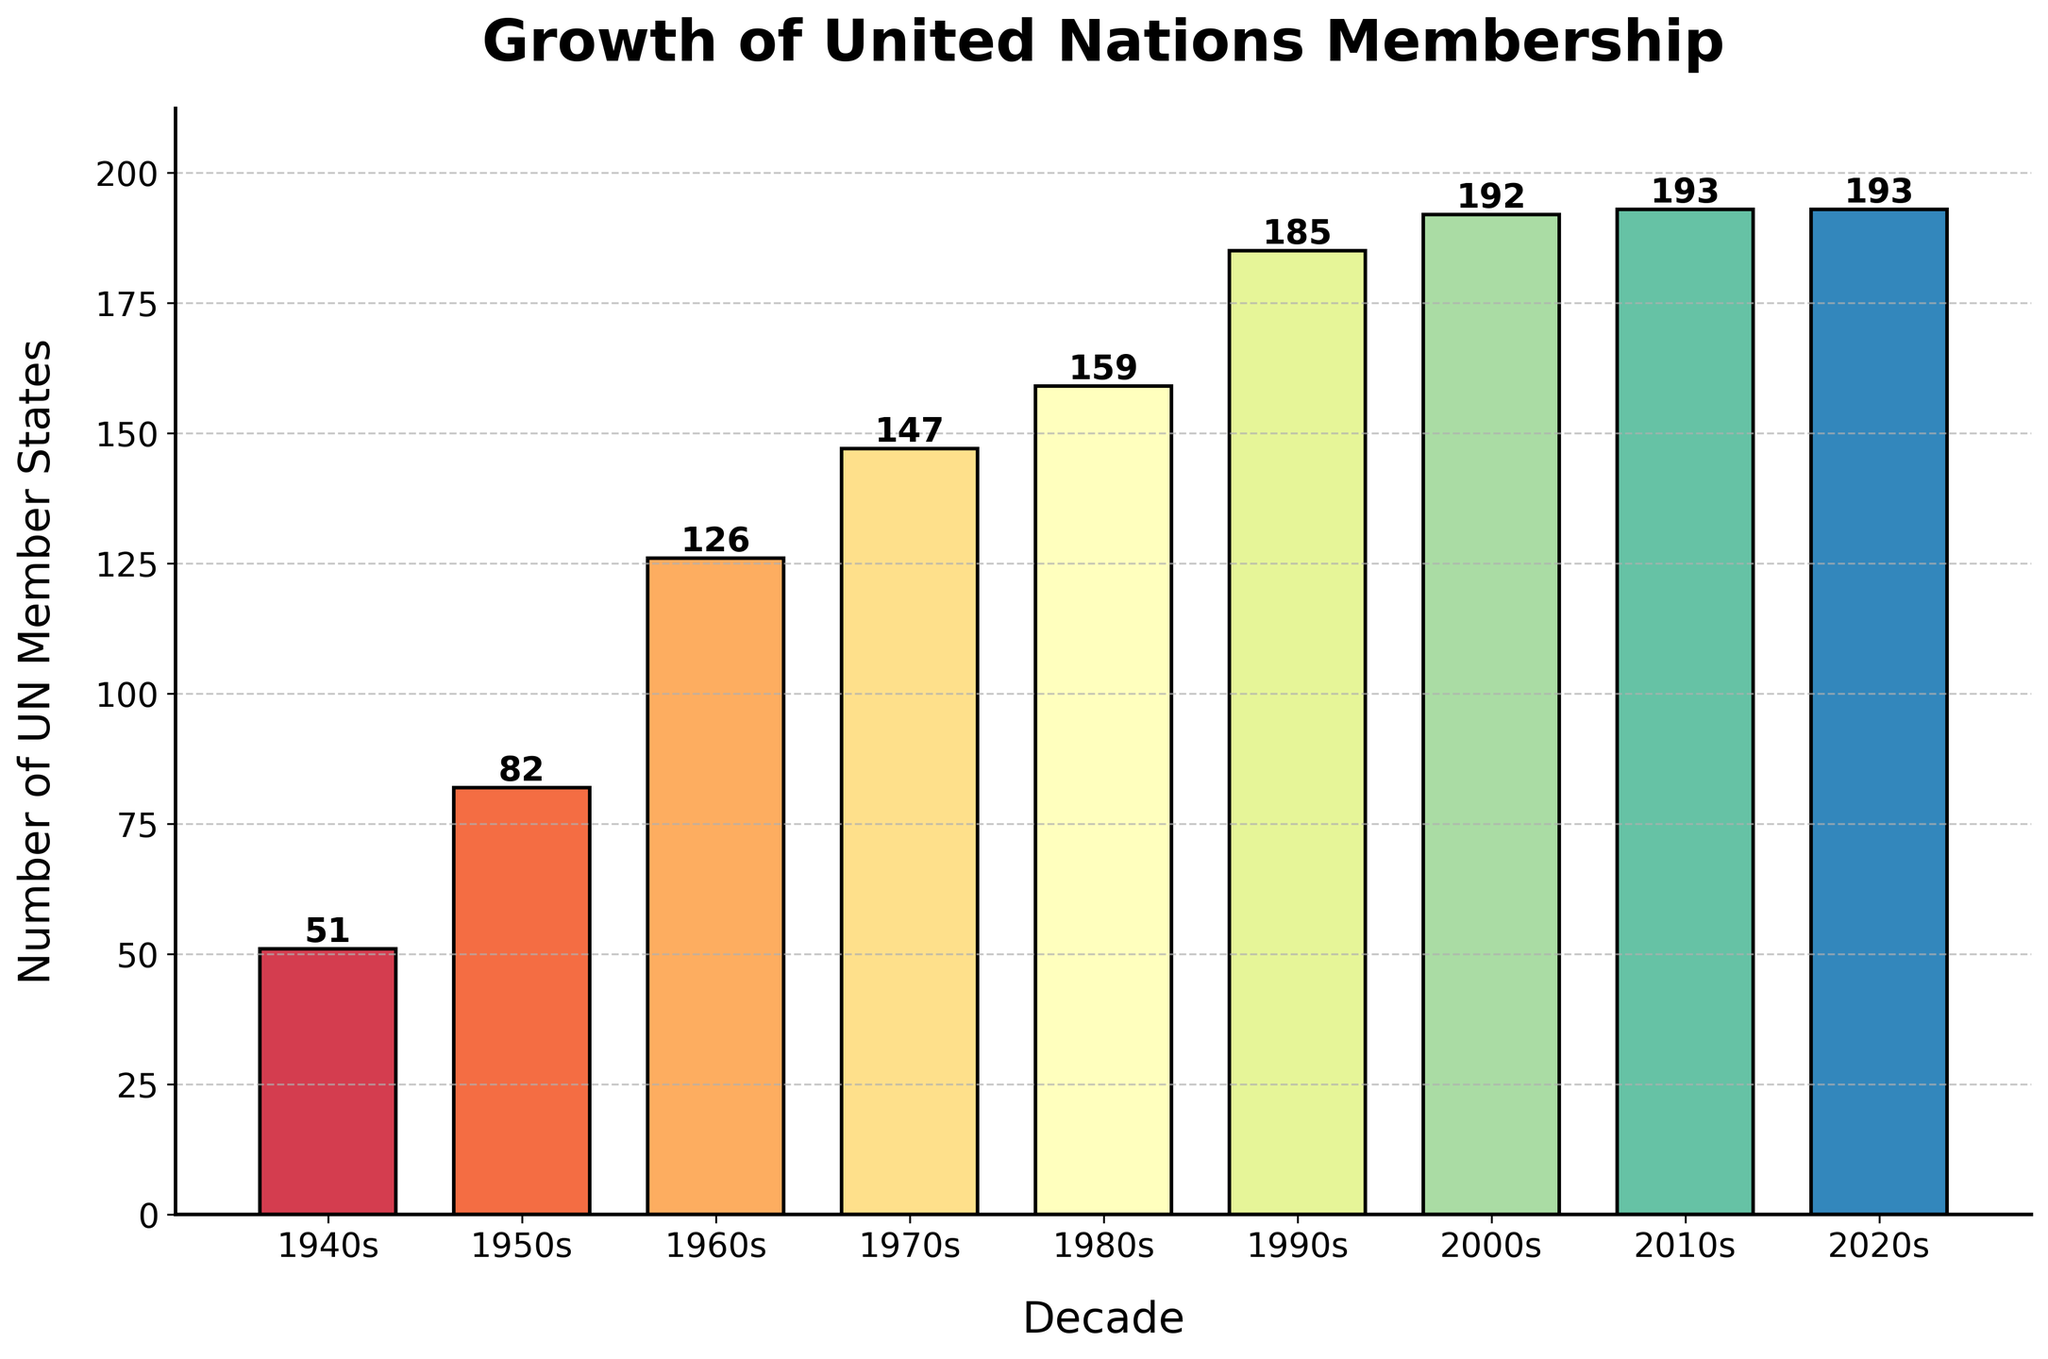What is the total increase in the number of UN member states from the 1940s to the 2020s? To find the total increase, subtract the number of states in the 1940s from that in the 2020s: 193 - 51 = 142
Answer: 142 Which decade saw the highest increase in the number of UN member states? Subtract the number of members of each decade from the previous one and identify the highest increase: 1950s: 82 - 51 = 31, 1960s: 126 - 82 = 44, 1970s: 147 - 126 = 21, 1980s: 159 - 147 = 12, 1990s: 185 - 159 = 26, 2000s: 192 - 185 = 7, 2010s: 193 - 192 = 1, 2020s: 193 - 193 = 0. The 1960s saw the highest increase of 44.
Answer: 1960s Compare the number of UN member states in the 1980s to the 1990s. Which decade had more member states and by how much? Subtract the number of member states in the 1980s from the number in the 1990s: 185 - 159 = 26. There are 26 more states in the 1990s.
Answer: 1990s by 26 What is the average number of UN member states from the 1940s to the 2020s? Calculate the average by summing the number of member states and dividing by the number of decades: (51 + 82 + 126 + 147 + 159 + 185 + 192 + 193 + 193) / 9 = 117.55 ≈ 118
Answer: 118 In which decade did the number of UN member states first exceed 100? Look at the numbers by decade and identify the first instance exceeding 100: 126 in the 1960s.
Answer: 1960s What is the difference in the number of UN member states between the 2010s and the 2000s? Subtract the number of member states in the 2000s from the number in the 2010s: 193 - 192 = 1.
Answer: 1 Visually, which decade has the tallest bar, indicating the highest number of UN member states? The 2020s bar is the tallest, indicating the highest number of 193 member states.
Answer: 2020s How many decades have a number of UN member states greater than 150? Count the decades with more than 150 member states: 1980s (159), 1990s (185), 2000s (192), 2010s (193), 2020s (193). This is 5 decades.
Answer: 5 What is the visual trend observed from the 1940s to the 2010s? The bars show an increasing trend in the number of UN member states over the decades, stabilizing after reaching the 2000s.
Answer: Increasing, stabilizing in the 2000s Which decade had the lowest number of UN member states? The bar representing the 1940s is the shortest, indicating the lowest number of 51 member states.
Answer: 1940s 